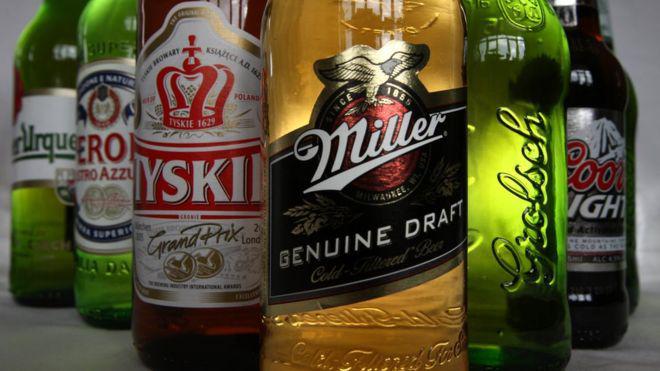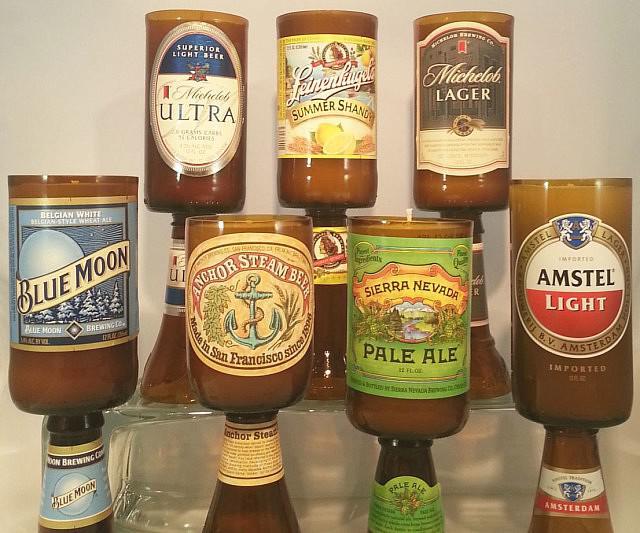The first image is the image on the left, the second image is the image on the right. For the images displayed, is the sentence "There are less than four bottles in one of the pictures." factually correct? Answer yes or no. No. 